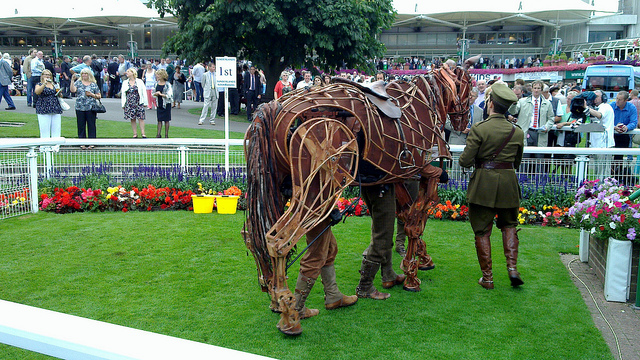Please transcribe the text in this image. 1st 